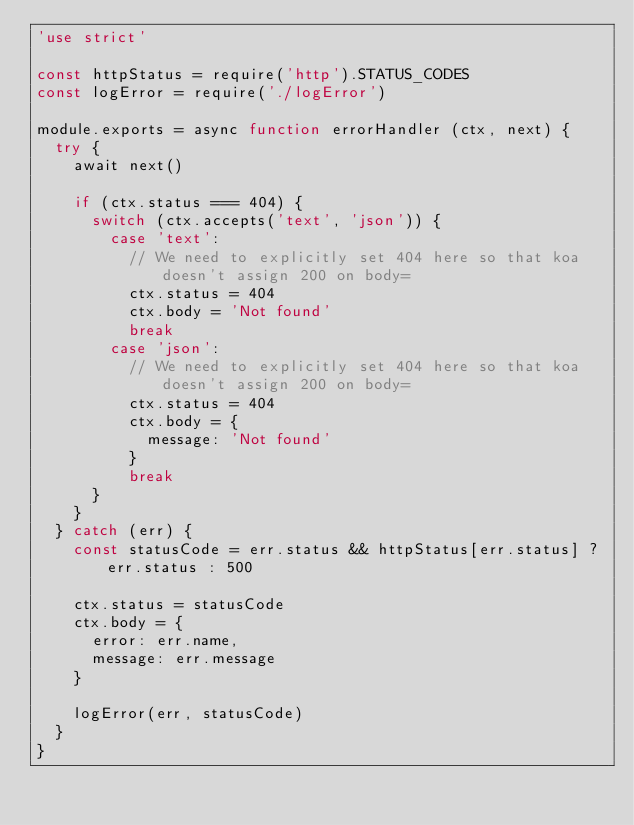<code> <loc_0><loc_0><loc_500><loc_500><_JavaScript_>'use strict'

const httpStatus = require('http').STATUS_CODES
const logError = require('./logError')

module.exports = async function errorHandler (ctx, next) {
  try {
    await next()

    if (ctx.status === 404) {
      switch (ctx.accepts('text', 'json')) {
        case 'text':
          // We need to explicitly set 404 here so that koa doesn't assign 200 on body=
          ctx.status = 404
          ctx.body = 'Not found'
          break
        case 'json':
          // We need to explicitly set 404 here so that koa doesn't assign 200 on body=
          ctx.status = 404
          ctx.body = {
            message: 'Not found'
          }
          break
      }
    }
  } catch (err) {
    const statusCode = err.status && httpStatus[err.status] ? err.status : 500

    ctx.status = statusCode
    ctx.body = {
      error: err.name,
      message: err.message
    }

    logError(err, statusCode)
  }
}
</code> 